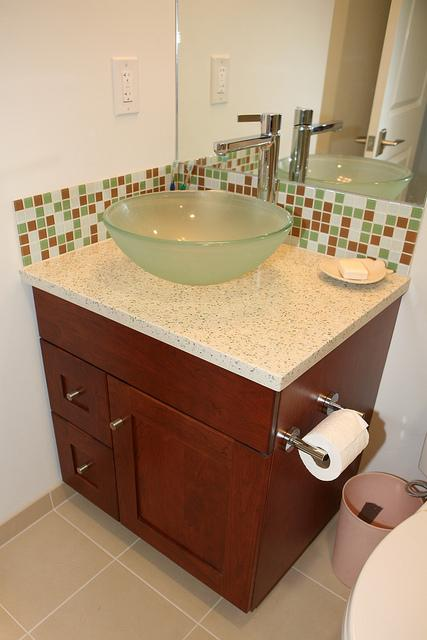What is the green bowl on the counter used for?

Choices:
A) eating
B) sifting
C) cooking
D) catching water catching water 